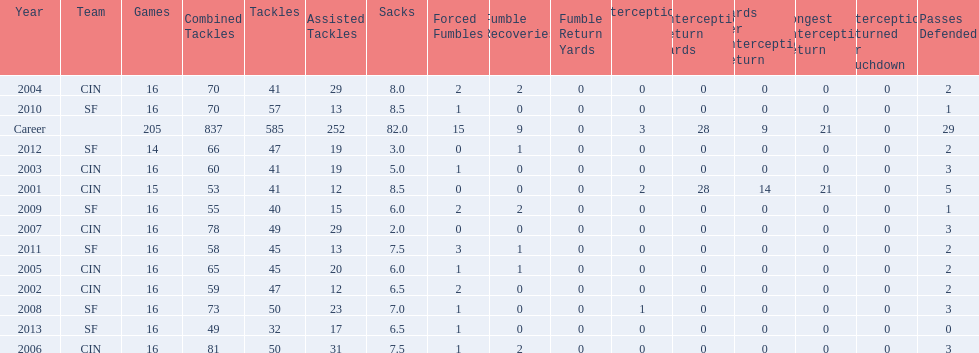What is the average number of tackles this player has had over his career? 45. Could you parse the entire table? {'header': ['Year', 'Team', 'Games', 'Combined Tackles', 'Tackles', 'Assisted Tackles', 'Sacks', 'Forced Fumbles', 'Fumble Recoveries', 'Fumble Return Yards', 'Interceptions', 'Interception Return Yards', 'Yards per Interception Return', 'Longest Interception Return', 'Interceptions Returned for Touchdown', 'Passes Defended'], 'rows': [['2004', 'CIN', '16', '70', '41', '29', '8.0', '2', '2', '0', '0', '0', '0', '0', '0', '2'], ['2010', 'SF', '16', '70', '57', '13', '8.5', '1', '0', '0', '0', '0', '0', '0', '0', '1'], ['Career', '', '205', '837', '585', '252', '82.0', '15', '9', '0', '3', '28', '9', '21', '0', '29'], ['2012', 'SF', '14', '66', '47', '19', '3.0', '0', '1', '0', '0', '0', '0', '0', '0', '2'], ['2003', 'CIN', '16', '60', '41', '19', '5.0', '1', '0', '0', '0', '0', '0', '0', '0', '3'], ['2001', 'CIN', '15', '53', '41', '12', '8.5', '0', '0', '0', '2', '28', '14', '21', '0', '5'], ['2009', 'SF', '16', '55', '40', '15', '6.0', '2', '2', '0', '0', '0', '0', '0', '0', '1'], ['2007', 'CIN', '16', '78', '49', '29', '2.0', '0', '0', '0', '0', '0', '0', '0', '0', '3'], ['2011', 'SF', '16', '58', '45', '13', '7.5', '3', '1', '0', '0', '0', '0', '0', '0', '2'], ['2005', 'CIN', '16', '65', '45', '20', '6.0', '1', '1', '0', '0', '0', '0', '0', '0', '2'], ['2002', 'CIN', '16', '59', '47', '12', '6.5', '2', '0', '0', '0', '0', '0', '0', '0', '2'], ['2008', 'SF', '16', '73', '50', '23', '7.0', '1', '0', '0', '1', '0', '0', '0', '0', '3'], ['2013', 'SF', '16', '49', '32', '17', '6.5', '1', '0', '0', '0', '0', '0', '0', '0', '0'], ['2006', 'CIN', '16', '81', '50', '31', '7.5', '1', '2', '0', '0', '0', '0', '0', '0', '3']]} 